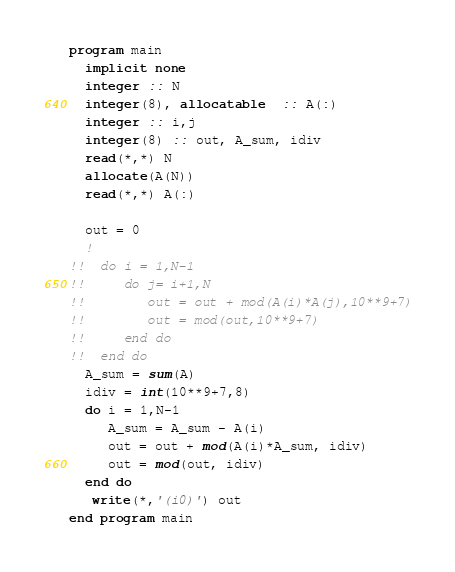<code> <loc_0><loc_0><loc_500><loc_500><_FORTRAN_>program main
  implicit none
  integer :: N
  integer(8), allocatable  :: A(:)
  integer :: i,j
  integer(8) :: out, A_sum, idiv
  read(*,*) N
  allocate(A(N))
  read(*,*) A(:)

  out = 0
  !
!!  do i = 1,N-1
!!     do j= i+1,N
!!        out = out + mod(A(i)*A(j),10**9+7)
!!        out = mod(out,10**9+7)
!!     end do
!!  end do
  A_sum = sum(A)
  idiv = int(10**9+7,8)
  do i = 1,N-1
     A_sum = A_sum - A(i)
     out = out + mod(A(i)*A_sum, idiv)
     out = mod(out, idiv)
  end do
   write(*,'(i0)') out
end program main
</code> 